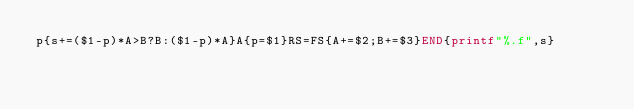<code> <loc_0><loc_0><loc_500><loc_500><_Awk_>p{s+=($1-p)*A>B?B:($1-p)*A}A{p=$1}RS=FS{A+=$2;B+=$3}END{printf"%.f",s}</code> 